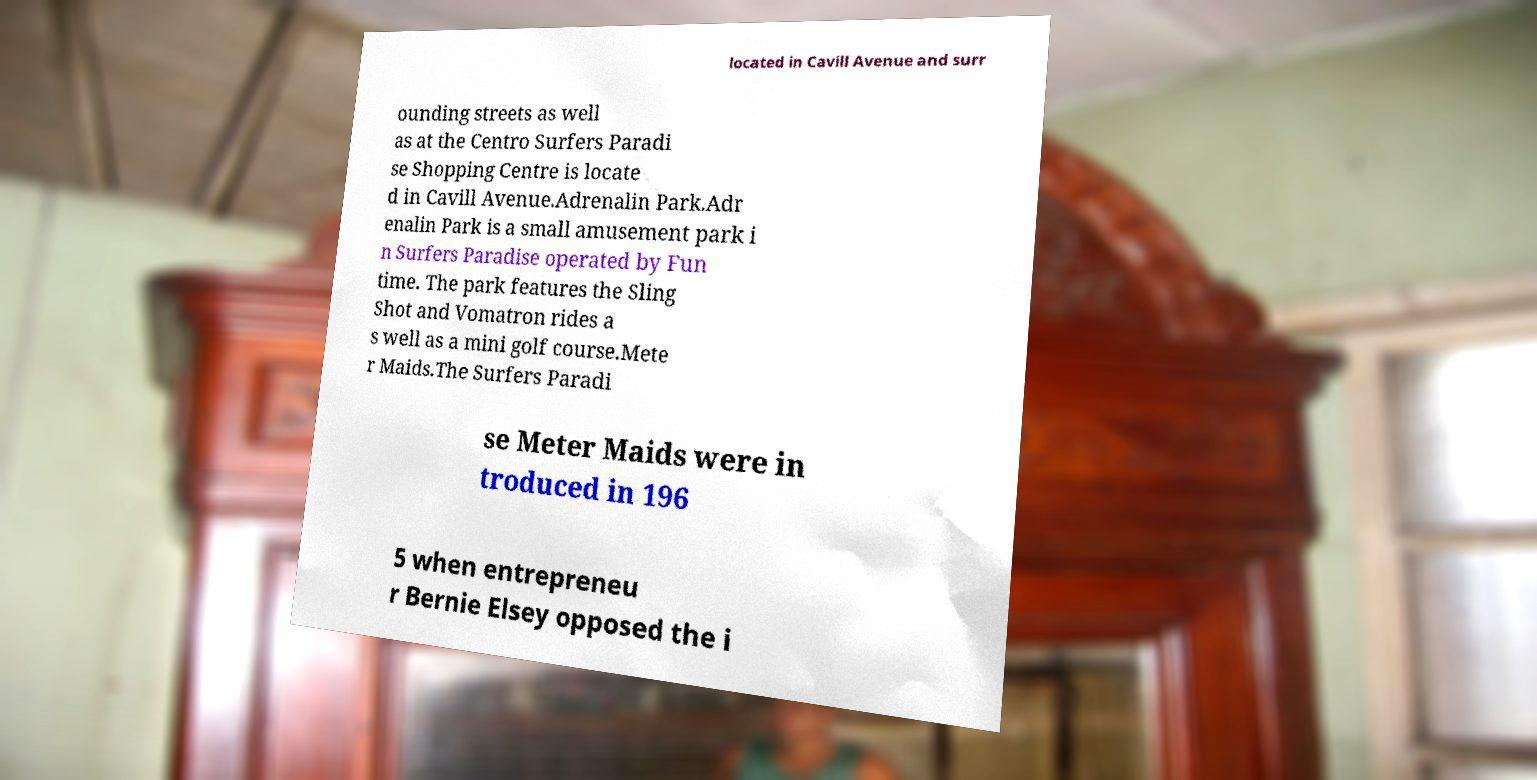There's text embedded in this image that I need extracted. Can you transcribe it verbatim? located in Cavill Avenue and surr ounding streets as well as at the Centro Surfers Paradi se Shopping Centre is locate d in Cavill Avenue.Adrenalin Park.Adr enalin Park is a small amusement park i n Surfers Paradise operated by Fun time. The park features the Sling Shot and Vomatron rides a s well as a mini golf course.Mete r Maids.The Surfers Paradi se Meter Maids were in troduced in 196 5 when entrepreneu r Bernie Elsey opposed the i 